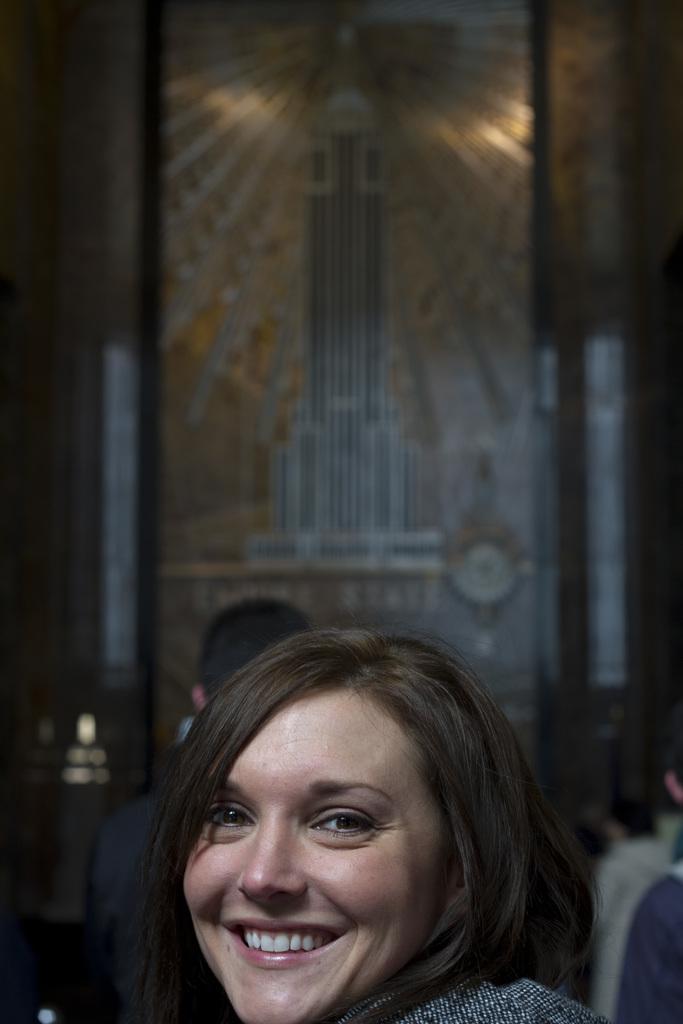In one or two sentences, can you explain what this image depicts? In the image there is a woman in the foreground, the background of the woman is blur. 